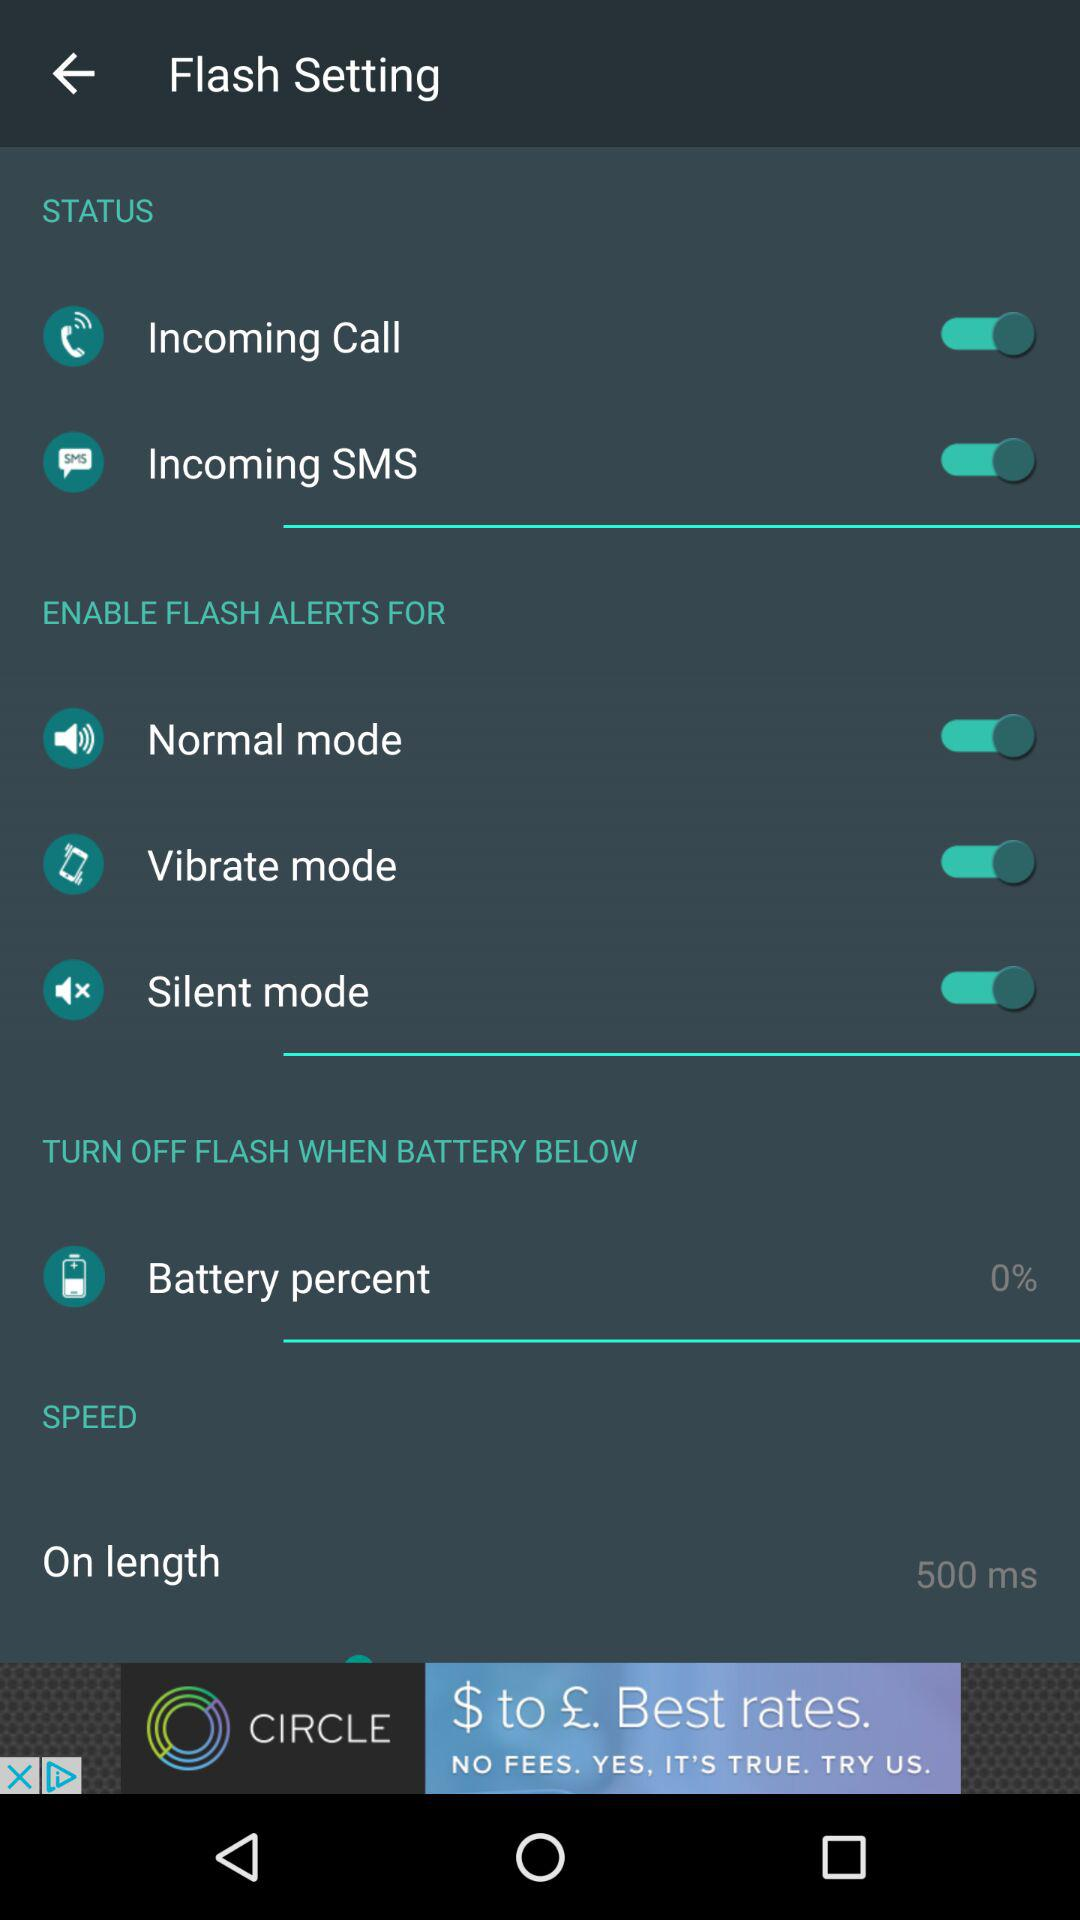What's the status of "Normal mode" in the "ENABLE FLASH ALERTS FOR" setting? The status of "Normal mode" is "on". 